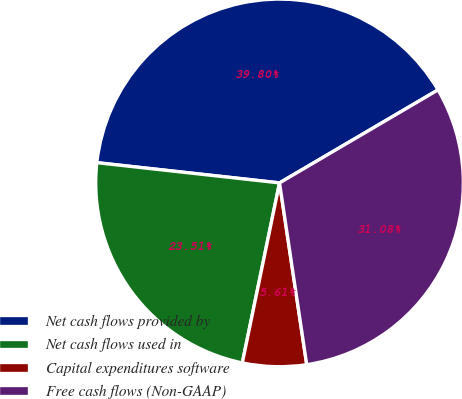<chart> <loc_0><loc_0><loc_500><loc_500><pie_chart><fcel>Net cash flows provided by<fcel>Net cash flows used in<fcel>Capital expenditures software<fcel>Free cash flows (Non-GAAP)<nl><fcel>39.8%<fcel>23.51%<fcel>5.61%<fcel>31.08%<nl></chart> 